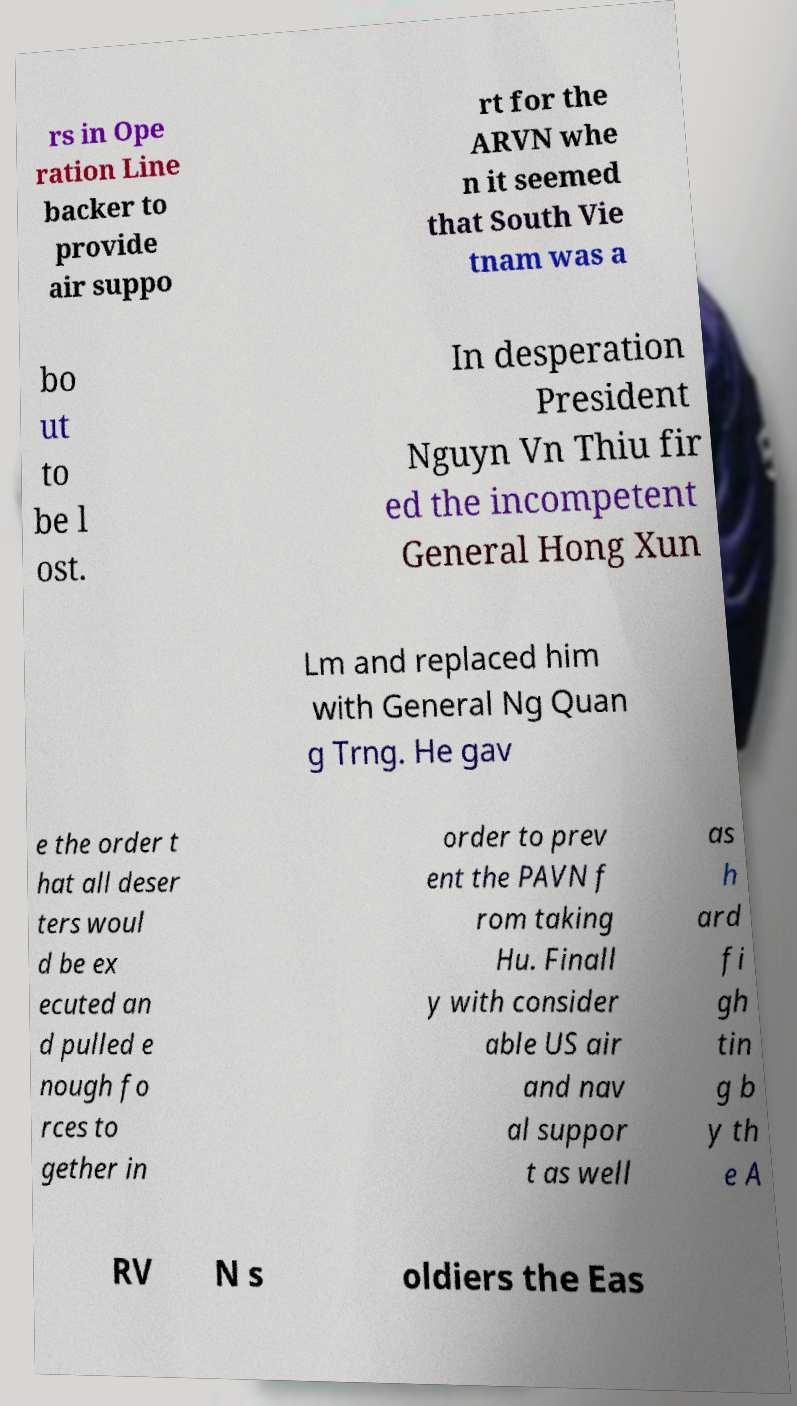Could you assist in decoding the text presented in this image and type it out clearly? rs in Ope ration Line backer to provide air suppo rt for the ARVN whe n it seemed that South Vie tnam was a bo ut to be l ost. In desperation President Nguyn Vn Thiu fir ed the incompetent General Hong Xun Lm and replaced him with General Ng Quan g Trng. He gav e the order t hat all deser ters woul d be ex ecuted an d pulled e nough fo rces to gether in order to prev ent the PAVN f rom taking Hu. Finall y with consider able US air and nav al suppor t as well as h ard fi gh tin g b y th e A RV N s oldiers the Eas 